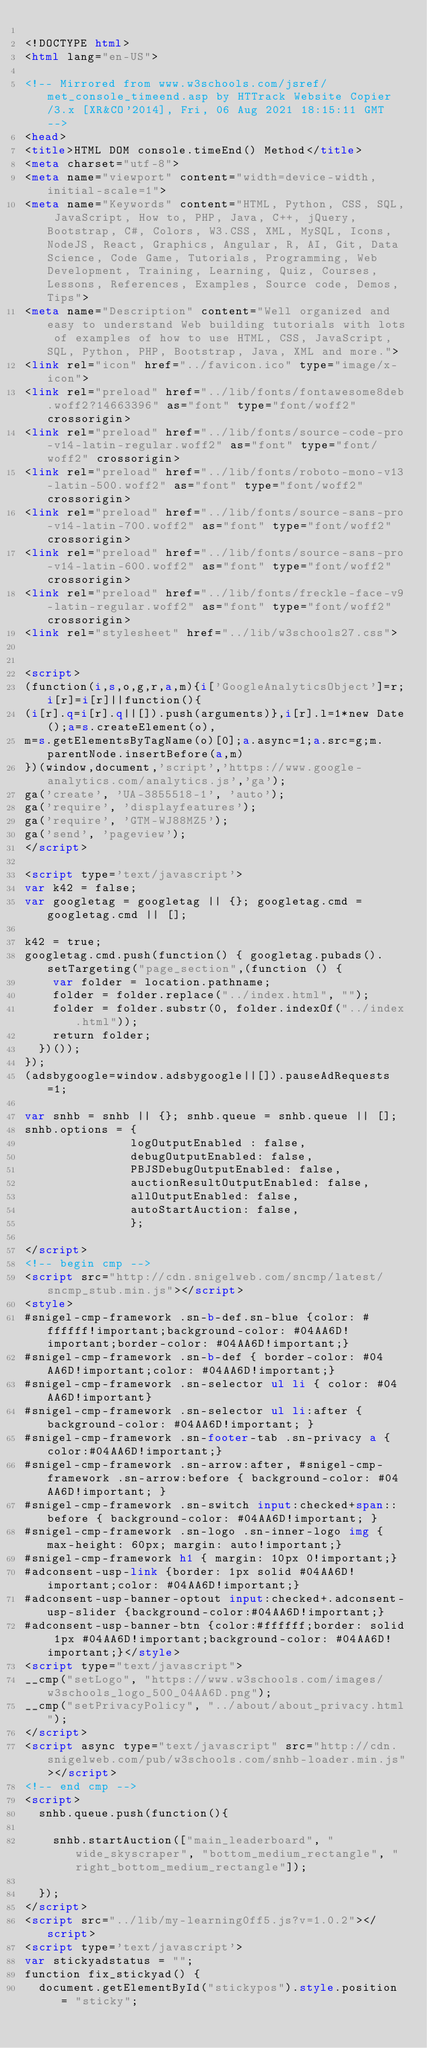Convert code to text. <code><loc_0><loc_0><loc_500><loc_500><_HTML_>
<!DOCTYPE html>
<html lang="en-US">

<!-- Mirrored from www.w3schools.com/jsref/met_console_timeend.asp by HTTrack Website Copier/3.x [XR&CO'2014], Fri, 06 Aug 2021 18:15:11 GMT -->
<head>
<title>HTML DOM console.timeEnd() Method</title>
<meta charset="utf-8">
<meta name="viewport" content="width=device-width, initial-scale=1">
<meta name="Keywords" content="HTML, Python, CSS, SQL, JavaScript, How to, PHP, Java, C++, jQuery, Bootstrap, C#, Colors, W3.CSS, XML, MySQL, Icons, NodeJS, React, Graphics, Angular, R, AI, Git, Data Science, Code Game, Tutorials, Programming, Web Development, Training, Learning, Quiz, Courses, Lessons, References, Examples, Source code, Demos, Tips">
<meta name="Description" content="Well organized and easy to understand Web building tutorials with lots of examples of how to use HTML, CSS, JavaScript, SQL, Python, PHP, Bootstrap, Java, XML and more.">
<link rel="icon" href="../favicon.ico" type="image/x-icon">
<link rel="preload" href="../lib/fonts/fontawesome8deb.woff2?14663396" as="font" type="font/woff2" crossorigin> 
<link rel="preload" href="../lib/fonts/source-code-pro-v14-latin-regular.woff2" as="font" type="font/woff2" crossorigin> 
<link rel="preload" href="../lib/fonts/roboto-mono-v13-latin-500.woff2" as="font" type="font/woff2" crossorigin> 
<link rel="preload" href="../lib/fonts/source-sans-pro-v14-latin-700.woff2" as="font" type="font/woff2" crossorigin> 
<link rel="preload" href="../lib/fonts/source-sans-pro-v14-latin-600.woff2" as="font" type="font/woff2" crossorigin> 
<link rel="preload" href="../lib/fonts/freckle-face-v9-latin-regular.woff2" as="font" type="font/woff2" crossorigin> 
<link rel="stylesheet" href="../lib/w3schools27.css">


<script>
(function(i,s,o,g,r,a,m){i['GoogleAnalyticsObject']=r;i[r]=i[r]||function(){
(i[r].q=i[r].q||[]).push(arguments)},i[r].l=1*new Date();a=s.createElement(o),
m=s.getElementsByTagName(o)[0];a.async=1;a.src=g;m.parentNode.insertBefore(a,m)
})(window,document,'script','https://www.google-analytics.com/analytics.js','ga');
ga('create', 'UA-3855518-1', 'auto');
ga('require', 'displayfeatures');
ga('require', 'GTM-WJ88MZ5');
ga('send', 'pageview');
</script>

<script type='text/javascript'>
var k42 = false;
var googletag = googletag || {}; googletag.cmd = googletag.cmd || [];

k42 = true;
googletag.cmd.push(function() { googletag.pubads().setTargeting("page_section",(function () {
    var folder = location.pathname;
    folder = folder.replace("../index.html", "");
    folder = folder.substr(0, folder.indexOf("../index.html"));
    return folder;
  })());
});  
(adsbygoogle=window.adsbygoogle||[]).pauseAdRequests=1;

var snhb = snhb || {}; snhb.queue = snhb.queue || [];
snhb.options = {
               logOutputEnabled : false,
               debugOutputEnabled: false,
               PBJSDebugOutputEnabled: false,
               auctionResultOutputEnabled: false,
               allOutputEnabled: false,
               autoStartAuction: false,
               };

</script>
<!-- begin cmp -->
<script src="http://cdn.snigelweb.com/sncmp/latest/sncmp_stub.min.js"></script>
<style>
#snigel-cmp-framework .sn-b-def.sn-blue {color: #ffffff!important;background-color: #04AA6D!important;border-color: #04AA6D!important;}
#snigel-cmp-framework .sn-b-def { border-color: #04AA6D!important;color: #04AA6D!important;}
#snigel-cmp-framework .sn-selector ul li { color: #04AA6D!important}
#snigel-cmp-framework .sn-selector ul li:after { background-color: #04AA6D!important; }
#snigel-cmp-framework .sn-footer-tab .sn-privacy a {color:#04AA6D!important;}
#snigel-cmp-framework .sn-arrow:after, #snigel-cmp-framework .sn-arrow:before { background-color: #04AA6D!important; }
#snigel-cmp-framework .sn-switch input:checked+span::before { background-color: #04AA6D!important; }
#snigel-cmp-framework .sn-logo .sn-inner-logo img { max-height: 60px; margin: auto!important;}
#snigel-cmp-framework h1 { margin: 10px 0!important;}
#adconsent-usp-link {border: 1px solid #04AA6D!important;color: #04AA6D!important;}
#adconsent-usp-banner-optout input:checked+.adconsent-usp-slider {background-color:#04AA6D!important;}
#adconsent-usp-banner-btn {color:#ffffff;border: solid 1px #04AA6D!important;background-color: #04AA6D!important;}</style>
<script type="text/javascript">
__cmp("setLogo", "https://www.w3schools.com/images/w3schools_logo_500_04AA6D.png");
__cmp("setPrivacyPolicy", "../about/about_privacy.html");
</script>
<script async type="text/javascript" src="http://cdn.snigelweb.com/pub/w3schools.com/snhb-loader.min.js"></script>
<!-- end cmp -->
<script>
  snhb.queue.push(function(){

    snhb.startAuction(["main_leaderboard", "wide_skyscraper", "bottom_medium_rectangle", "right_bottom_medium_rectangle"]);

  });
</script>
<script src="../lib/my-learning0ff5.js?v=1.0.2"></script>
<script type='text/javascript'>
var stickyadstatus = "";
function fix_stickyad() {
  document.getElementById("stickypos").style.position = "sticky";</code> 